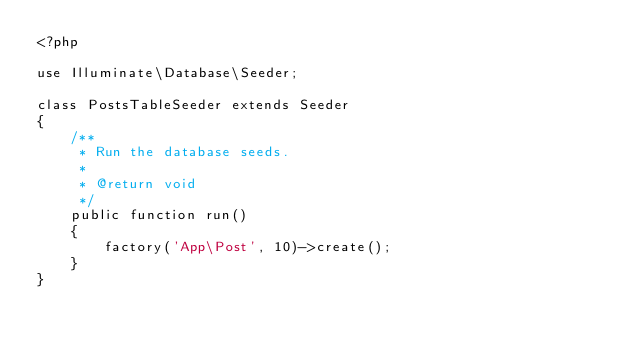Convert code to text. <code><loc_0><loc_0><loc_500><loc_500><_PHP_><?php

use Illuminate\Database\Seeder;

class PostsTableSeeder extends Seeder
{
    /**
     * Run the database seeds.
     *
     * @return void
     */
    public function run()
    {
        factory('App\Post', 10)->create();
    }
}
</code> 